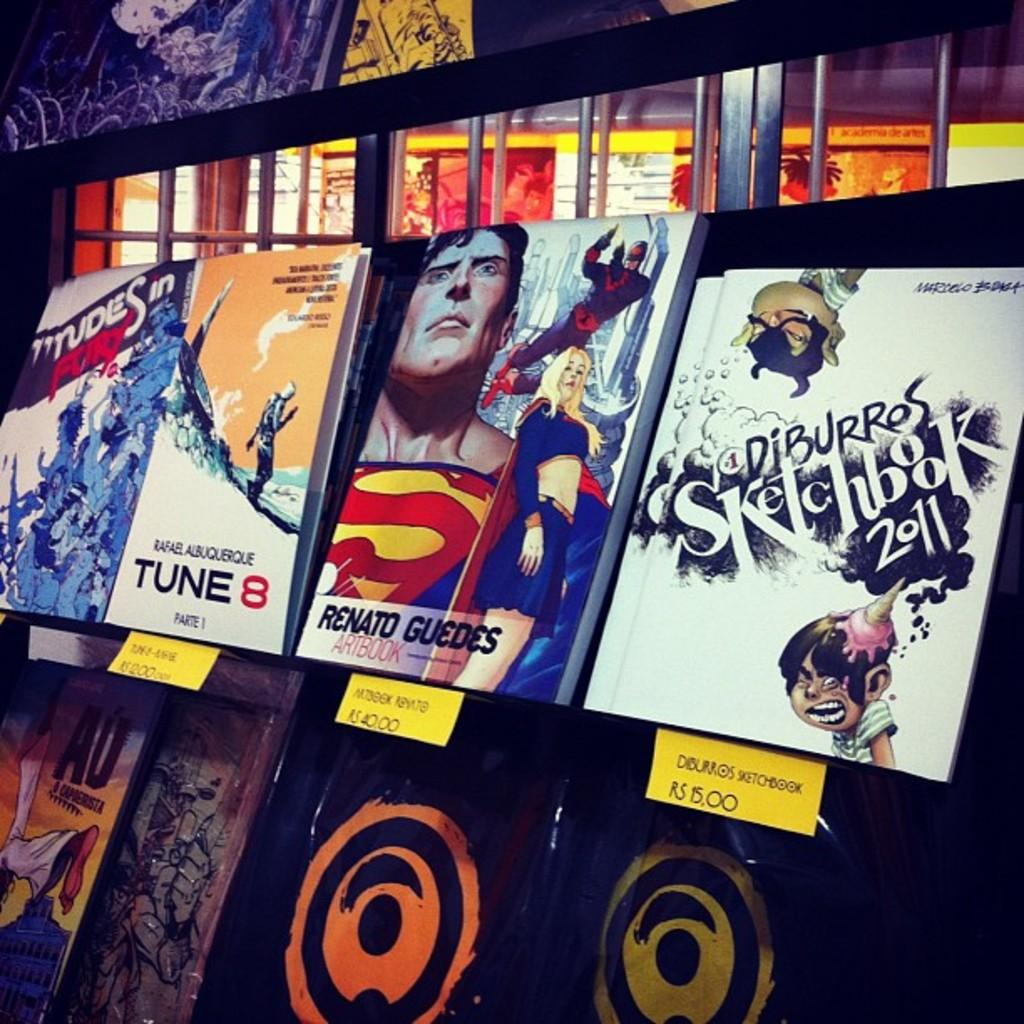<image>
Give a short and clear explanation of the subsequent image. Different books are lined up with the prices below them, including a Diburros Sketchbook 2011. 